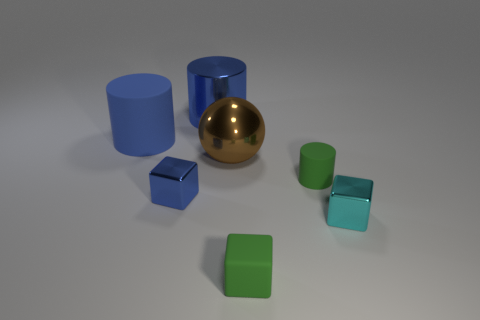Are there more tiny brown metal blocks than big things?
Keep it short and to the point. No. There is a blue shiny cube; is its size the same as the cylinder on the left side of the blue metallic cylinder?
Provide a succinct answer. No. The rubber cylinder in front of the blue rubber cylinder is what color?
Make the answer very short. Green. How many green things are large shiny balls or rubber objects?
Your response must be concise. 2. The matte cube is what color?
Give a very brief answer. Green. Is there anything else that is the same material as the brown thing?
Your response must be concise. Yes. Are there fewer big brown balls that are in front of the tiny cyan shiny thing than large brown metal balls to the left of the large blue rubber object?
Keep it short and to the point. No. There is a matte object that is behind the small green block and on the right side of the large sphere; what shape is it?
Keep it short and to the point. Cylinder. How many large brown metallic things have the same shape as the cyan metal thing?
Your response must be concise. 0. There is a sphere that is the same material as the blue block; what size is it?
Your answer should be very brief. Large. 